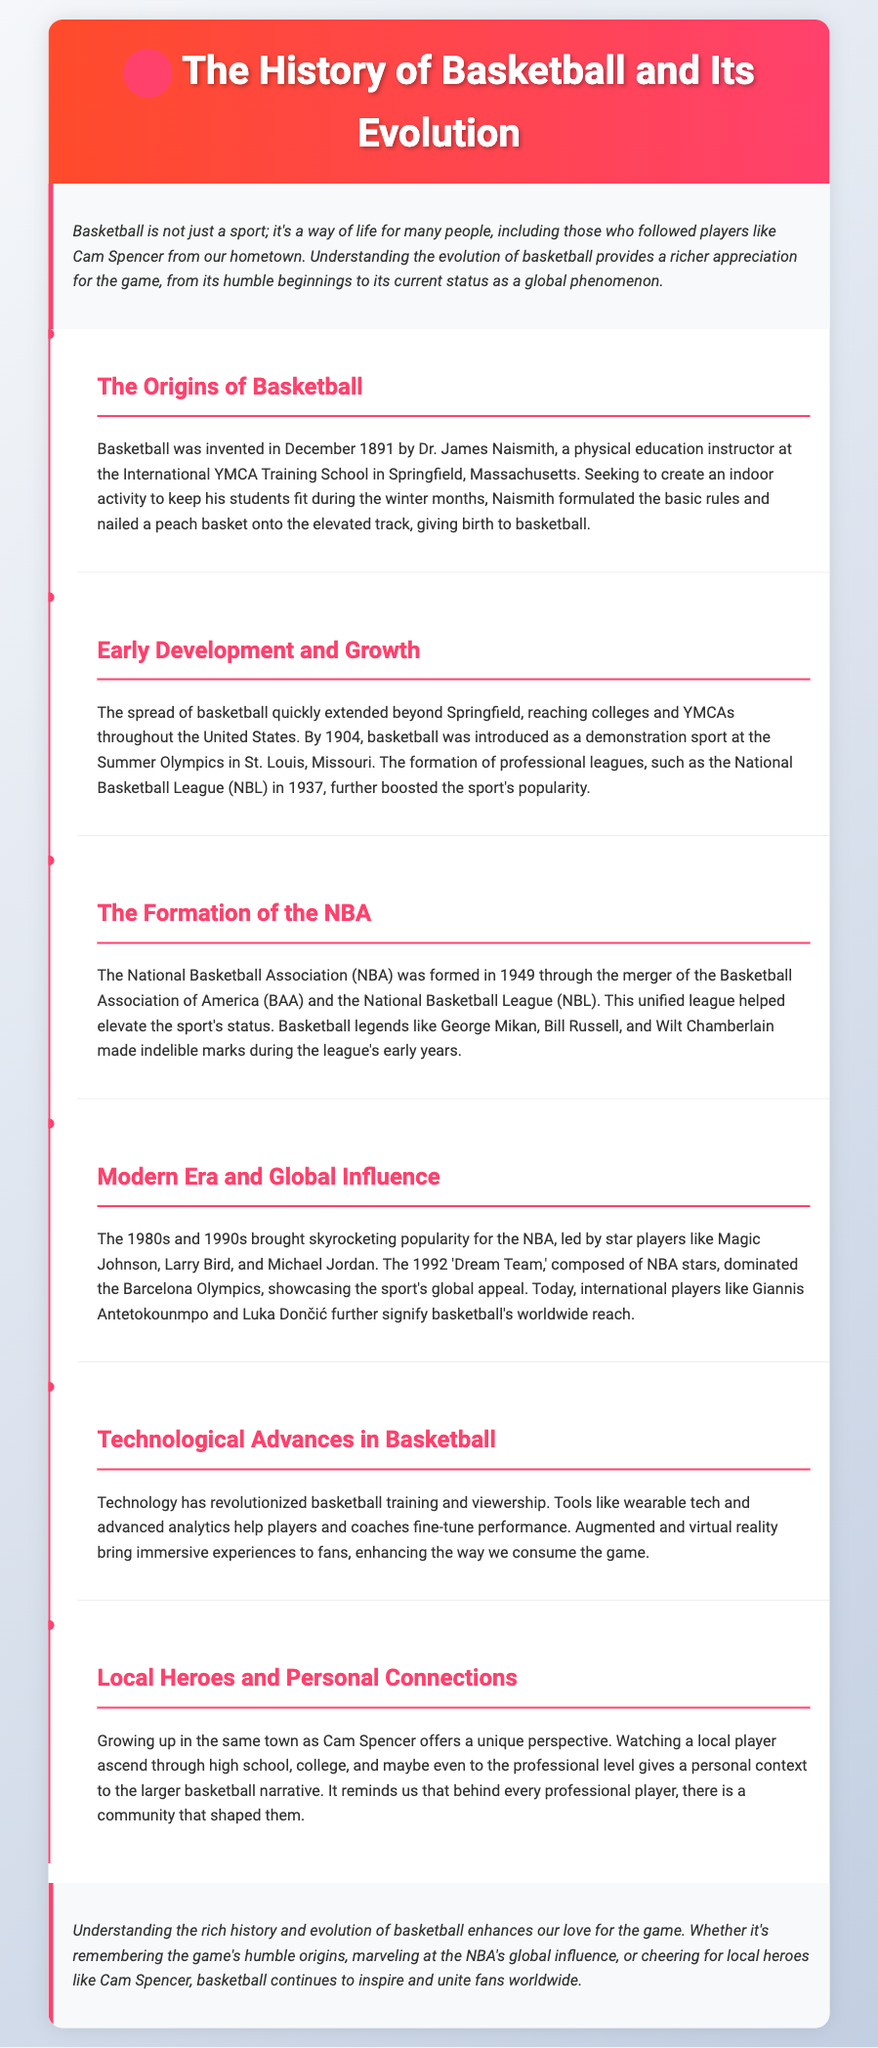What year was basketball invented? Basketball was invented in December 1891 by Dr. James Naismith.
Answer: 1891 Who introduced basketball as a demonstration sport at the Summer Olympics? Basketball was introduced by the Olympic committee for the Summer Olympics in St. Louis, Missouri.
Answer: St. Louis What professional league was formed in 1937? The National Basketball League (NBL) was formed in 1937.
Answer: NBL What teams merged to form the NBA? The NBA was formed through the merger of the Basketball Association of America (BAA) and the National Basketball League (NBL).
Answer: BAA and NBL Which players are mentioned as stars who contributed to the NBA's popularity in the 1980s and 1990s? Magic Johnson, Larry Bird, and Michael Jordan are mentioned as stars.
Answer: Magic Johnson, Larry Bird, and Michael Jordan What year did the 'Dream Team' dominate the Barcelona Olympics? The 'Dream Team' dominated the Olympics in 1992.
Answer: 1992 How has technology impacted basketball training and viewership? Technology has revolutionized basketball training with tools like wearable tech and advanced analytics.
Answer: Wearable tech and advanced analytics Who is a local hero mentioned in the document? Cam Spencer is mentioned as a local hero in the document.
Answer: Cam Spencer What is the main purpose of understanding basketball's history according to the conclusion? The main purpose is to enhance our love for the game.
Answer: Enhance our love for the game 